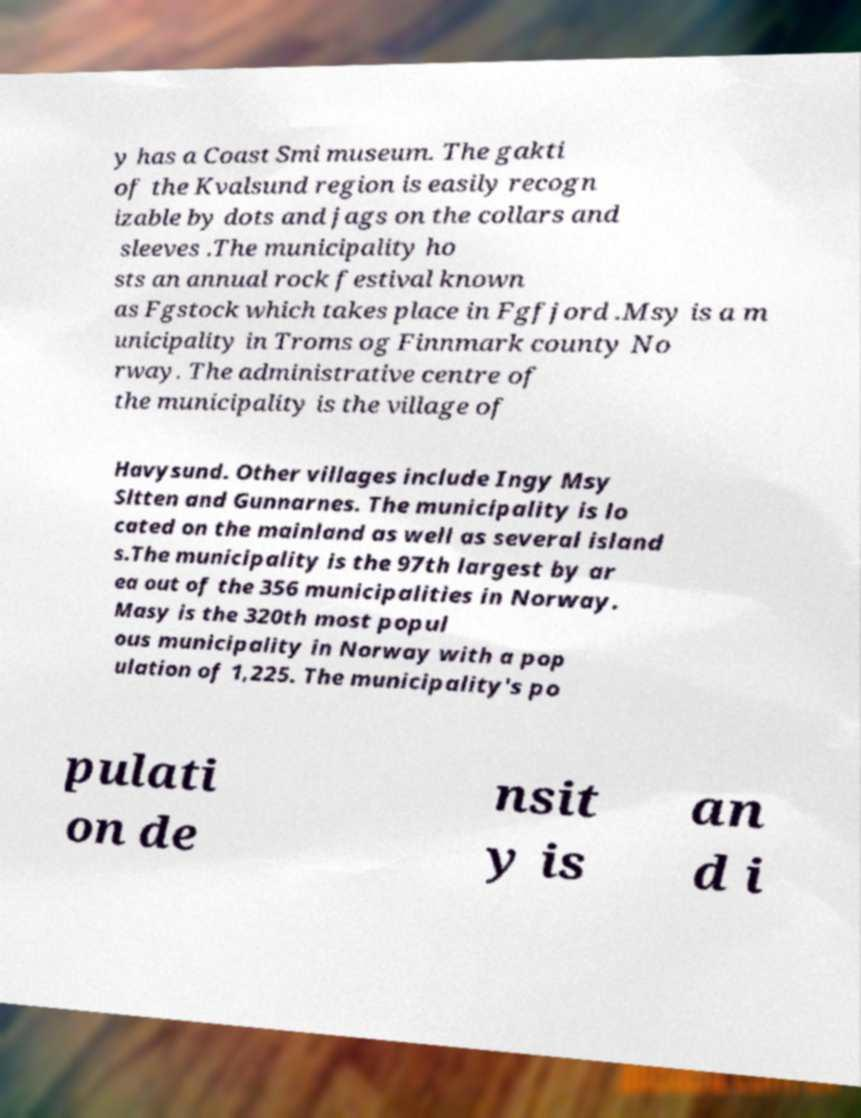Can you read and provide the text displayed in the image?This photo seems to have some interesting text. Can you extract and type it out for me? y has a Coast Smi museum. The gakti of the Kvalsund region is easily recogn izable by dots and jags on the collars and sleeves .The municipality ho sts an annual rock festival known as Fgstock which takes place in Fgfjord .Msy is a m unicipality in Troms og Finnmark county No rway. The administrative centre of the municipality is the village of Havysund. Other villages include Ingy Msy Sltten and Gunnarnes. The municipality is lo cated on the mainland as well as several island s.The municipality is the 97th largest by ar ea out of the 356 municipalities in Norway. Masy is the 320th most popul ous municipality in Norway with a pop ulation of 1,225. The municipality's po pulati on de nsit y is an d i 